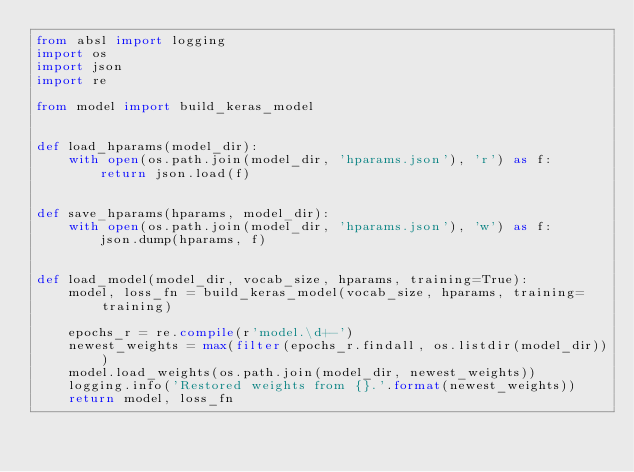Convert code to text. <code><loc_0><loc_0><loc_500><loc_500><_Python_>from absl import logging
import os
import json
import re

from model import build_keras_model


def load_hparams(model_dir):
    with open(os.path.join(model_dir, 'hparams.json'), 'r') as f:
        return json.load(f)


def save_hparams(hparams, model_dir):
    with open(os.path.join(model_dir, 'hparams.json'), 'w') as f:
        json.dump(hparams, f)


def load_model(model_dir, vocab_size, hparams, training=True):
    model, loss_fn = build_keras_model(vocab_size, hparams, training=training)
    
    epochs_r = re.compile(r'model.\d+-')
    newest_weights = max(filter(epochs_r.findall, os.listdir(model_dir)))
    model.load_weights(os.path.join(model_dir, newest_weights))
    logging.info('Restored weights from {}.'.format(newest_weights))
    return model, loss_fn</code> 